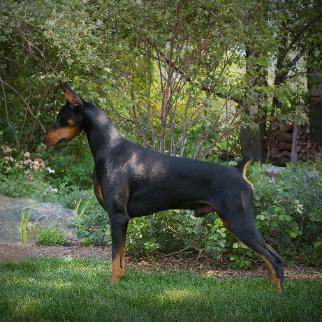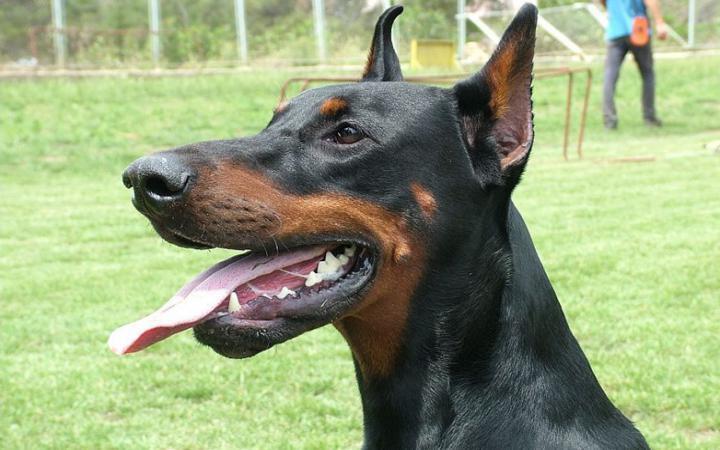The first image is the image on the left, the second image is the image on the right. Considering the images on both sides, is "The right image contains no more than three dogs." valid? Answer yes or no. Yes. The first image is the image on the left, the second image is the image on the right. Examine the images to the left and right. Is the description "The left image contains one rightward-gazing doberman with erect ears, and the right image features a reclining doberman accompanied by at least three other dogs." accurate? Answer yes or no. No. 